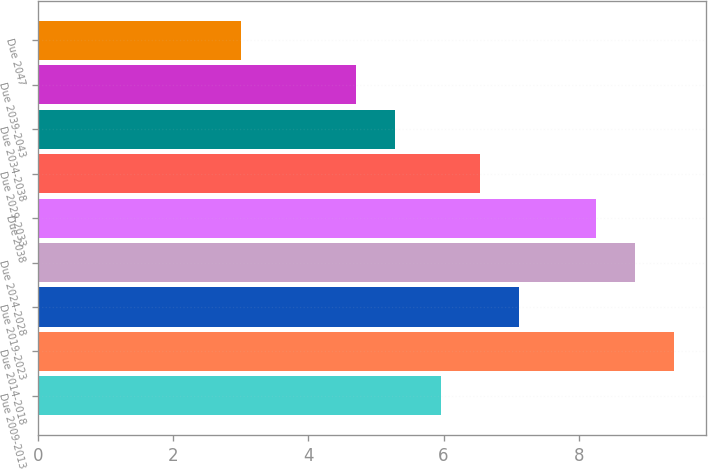Convert chart. <chart><loc_0><loc_0><loc_500><loc_500><bar_chart><fcel>Due 2009-2013<fcel>Due 2014-2018<fcel>Due 2019-2023<fcel>Due 2024-2028<fcel>Due 2038<fcel>Due 2029-2033<fcel>Due 2034-2038<fcel>Due 2039-2043<fcel>Due 2047<nl><fcel>5.96<fcel>9.41<fcel>7.12<fcel>8.83<fcel>8.25<fcel>6.54<fcel>5.28<fcel>4.7<fcel>3<nl></chart> 